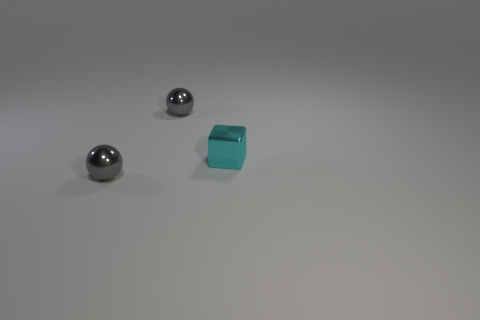Are the three objects made from the same material? The two spherical objects appear to be made of a reflective material, quite likely metal, while the block looks to have a matte finish, suggesting it could be made of a different substance, perhaps plastic. 